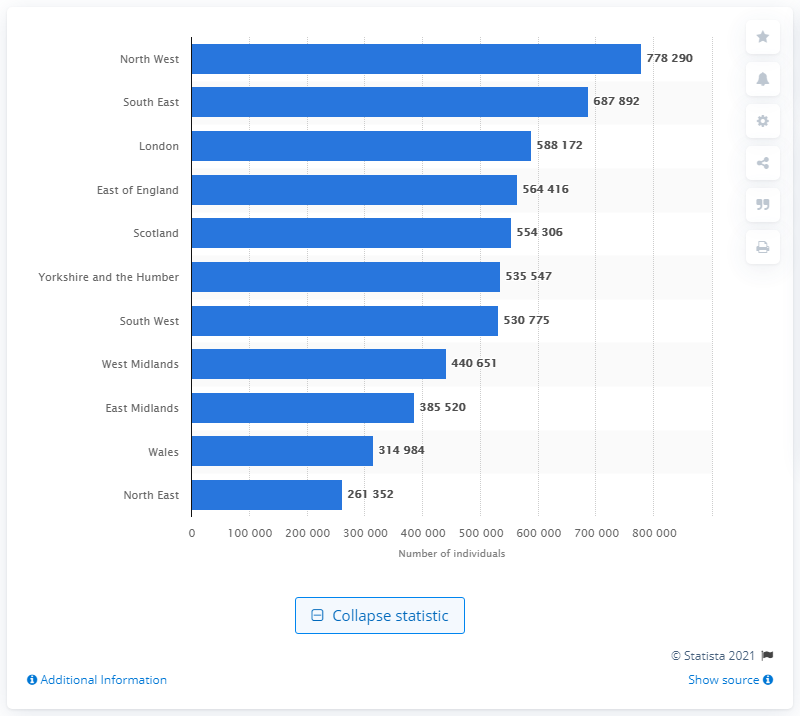Can you tell me which region had the highest number of individuals with asthma according to this chart? According to the chart, the North West had the highest number of individuals with asthma, numbering 778,290. 